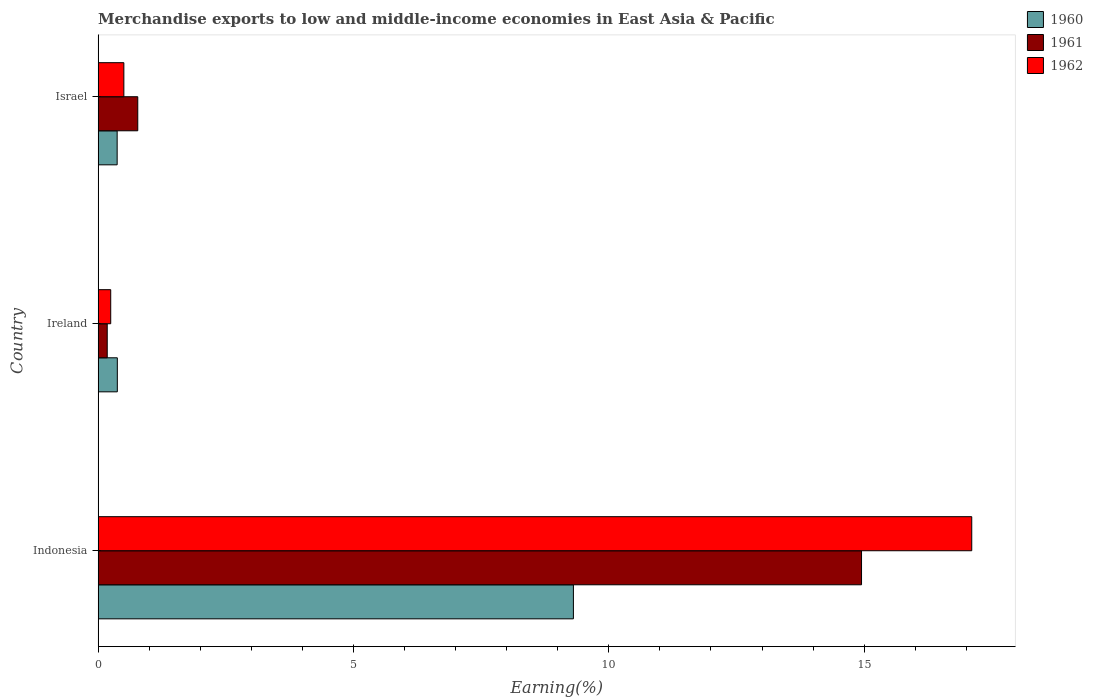How many groups of bars are there?
Give a very brief answer. 3. Are the number of bars per tick equal to the number of legend labels?
Your response must be concise. Yes. Are the number of bars on each tick of the Y-axis equal?
Provide a short and direct response. Yes. How many bars are there on the 2nd tick from the top?
Make the answer very short. 3. How many bars are there on the 2nd tick from the bottom?
Provide a short and direct response. 3. What is the label of the 1st group of bars from the top?
Your answer should be compact. Israel. What is the percentage of amount earned from merchandise exports in 1960 in Indonesia?
Keep it short and to the point. 9.31. Across all countries, what is the maximum percentage of amount earned from merchandise exports in 1960?
Provide a succinct answer. 9.31. Across all countries, what is the minimum percentage of amount earned from merchandise exports in 1960?
Give a very brief answer. 0.37. In which country was the percentage of amount earned from merchandise exports in 1961 maximum?
Your answer should be compact. Indonesia. In which country was the percentage of amount earned from merchandise exports in 1961 minimum?
Keep it short and to the point. Ireland. What is the total percentage of amount earned from merchandise exports in 1962 in the graph?
Offer a very short reply. 17.86. What is the difference between the percentage of amount earned from merchandise exports in 1962 in Ireland and that in Israel?
Ensure brevity in your answer.  -0.26. What is the difference between the percentage of amount earned from merchandise exports in 1962 in Israel and the percentage of amount earned from merchandise exports in 1960 in Ireland?
Your answer should be very brief. 0.13. What is the average percentage of amount earned from merchandise exports in 1961 per country?
Provide a succinct answer. 5.3. What is the difference between the percentage of amount earned from merchandise exports in 1962 and percentage of amount earned from merchandise exports in 1960 in Indonesia?
Ensure brevity in your answer.  7.8. In how many countries, is the percentage of amount earned from merchandise exports in 1961 greater than 6 %?
Ensure brevity in your answer.  1. What is the ratio of the percentage of amount earned from merchandise exports in 1961 in Indonesia to that in Ireland?
Make the answer very short. 83.74. Is the percentage of amount earned from merchandise exports in 1960 in Indonesia less than that in Israel?
Provide a succinct answer. No. What is the difference between the highest and the second highest percentage of amount earned from merchandise exports in 1962?
Your answer should be compact. 16.6. What is the difference between the highest and the lowest percentage of amount earned from merchandise exports in 1961?
Your answer should be compact. 14.77. In how many countries, is the percentage of amount earned from merchandise exports in 1960 greater than the average percentage of amount earned from merchandise exports in 1960 taken over all countries?
Offer a very short reply. 1. Is the sum of the percentage of amount earned from merchandise exports in 1960 in Indonesia and Israel greater than the maximum percentage of amount earned from merchandise exports in 1961 across all countries?
Provide a succinct answer. No. What does the 3rd bar from the bottom in Israel represents?
Make the answer very short. 1962. Is it the case that in every country, the sum of the percentage of amount earned from merchandise exports in 1961 and percentage of amount earned from merchandise exports in 1960 is greater than the percentage of amount earned from merchandise exports in 1962?
Give a very brief answer. Yes. How many bars are there?
Provide a succinct answer. 9. What is the difference between two consecutive major ticks on the X-axis?
Provide a succinct answer. 5. Does the graph contain any zero values?
Your answer should be compact. No. Does the graph contain grids?
Ensure brevity in your answer.  No. Where does the legend appear in the graph?
Offer a terse response. Top right. How many legend labels are there?
Your response must be concise. 3. How are the legend labels stacked?
Give a very brief answer. Vertical. What is the title of the graph?
Your response must be concise. Merchandise exports to low and middle-income economies in East Asia & Pacific. What is the label or title of the X-axis?
Make the answer very short. Earning(%). What is the label or title of the Y-axis?
Offer a terse response. Country. What is the Earning(%) of 1960 in Indonesia?
Keep it short and to the point. 9.31. What is the Earning(%) in 1961 in Indonesia?
Your response must be concise. 14.95. What is the Earning(%) of 1962 in Indonesia?
Make the answer very short. 17.11. What is the Earning(%) of 1960 in Ireland?
Ensure brevity in your answer.  0.38. What is the Earning(%) in 1961 in Ireland?
Give a very brief answer. 0.18. What is the Earning(%) of 1962 in Ireland?
Give a very brief answer. 0.25. What is the Earning(%) in 1960 in Israel?
Your answer should be very brief. 0.37. What is the Earning(%) of 1961 in Israel?
Your answer should be compact. 0.78. What is the Earning(%) of 1962 in Israel?
Offer a very short reply. 0.5. Across all countries, what is the maximum Earning(%) in 1960?
Offer a very short reply. 9.31. Across all countries, what is the maximum Earning(%) in 1961?
Keep it short and to the point. 14.95. Across all countries, what is the maximum Earning(%) of 1962?
Provide a short and direct response. 17.11. Across all countries, what is the minimum Earning(%) of 1960?
Your response must be concise. 0.37. Across all countries, what is the minimum Earning(%) in 1961?
Make the answer very short. 0.18. Across all countries, what is the minimum Earning(%) of 1962?
Offer a terse response. 0.25. What is the total Earning(%) in 1960 in the graph?
Your answer should be compact. 10.06. What is the total Earning(%) of 1961 in the graph?
Your response must be concise. 15.9. What is the total Earning(%) of 1962 in the graph?
Make the answer very short. 17.86. What is the difference between the Earning(%) of 1960 in Indonesia and that in Ireland?
Offer a very short reply. 8.93. What is the difference between the Earning(%) of 1961 in Indonesia and that in Ireland?
Your response must be concise. 14.77. What is the difference between the Earning(%) in 1962 in Indonesia and that in Ireland?
Your response must be concise. 16.86. What is the difference between the Earning(%) in 1960 in Indonesia and that in Israel?
Give a very brief answer. 8.93. What is the difference between the Earning(%) of 1961 in Indonesia and that in Israel?
Give a very brief answer. 14.17. What is the difference between the Earning(%) in 1962 in Indonesia and that in Israel?
Keep it short and to the point. 16.6. What is the difference between the Earning(%) in 1960 in Ireland and that in Israel?
Your response must be concise. 0. What is the difference between the Earning(%) of 1961 in Ireland and that in Israel?
Keep it short and to the point. -0.6. What is the difference between the Earning(%) in 1962 in Ireland and that in Israel?
Your answer should be compact. -0.26. What is the difference between the Earning(%) in 1960 in Indonesia and the Earning(%) in 1961 in Ireland?
Ensure brevity in your answer.  9.13. What is the difference between the Earning(%) in 1960 in Indonesia and the Earning(%) in 1962 in Ireland?
Keep it short and to the point. 9.06. What is the difference between the Earning(%) of 1961 in Indonesia and the Earning(%) of 1962 in Ireland?
Make the answer very short. 14.7. What is the difference between the Earning(%) in 1960 in Indonesia and the Earning(%) in 1961 in Israel?
Make the answer very short. 8.53. What is the difference between the Earning(%) in 1960 in Indonesia and the Earning(%) in 1962 in Israel?
Offer a terse response. 8.8. What is the difference between the Earning(%) of 1961 in Indonesia and the Earning(%) of 1962 in Israel?
Your answer should be very brief. 14.44. What is the difference between the Earning(%) of 1960 in Ireland and the Earning(%) of 1961 in Israel?
Ensure brevity in your answer.  -0.4. What is the difference between the Earning(%) of 1960 in Ireland and the Earning(%) of 1962 in Israel?
Ensure brevity in your answer.  -0.13. What is the difference between the Earning(%) in 1961 in Ireland and the Earning(%) in 1962 in Israel?
Make the answer very short. -0.33. What is the average Earning(%) of 1960 per country?
Ensure brevity in your answer.  3.35. What is the average Earning(%) in 1961 per country?
Make the answer very short. 5.3. What is the average Earning(%) in 1962 per country?
Your answer should be compact. 5.95. What is the difference between the Earning(%) in 1960 and Earning(%) in 1961 in Indonesia?
Your answer should be compact. -5.64. What is the difference between the Earning(%) of 1960 and Earning(%) of 1962 in Indonesia?
Provide a succinct answer. -7.8. What is the difference between the Earning(%) in 1961 and Earning(%) in 1962 in Indonesia?
Ensure brevity in your answer.  -2.16. What is the difference between the Earning(%) of 1960 and Earning(%) of 1961 in Ireland?
Give a very brief answer. 0.2. What is the difference between the Earning(%) of 1960 and Earning(%) of 1962 in Ireland?
Your answer should be very brief. 0.13. What is the difference between the Earning(%) in 1961 and Earning(%) in 1962 in Ireland?
Give a very brief answer. -0.07. What is the difference between the Earning(%) of 1960 and Earning(%) of 1961 in Israel?
Keep it short and to the point. -0.4. What is the difference between the Earning(%) in 1960 and Earning(%) in 1962 in Israel?
Your answer should be compact. -0.13. What is the difference between the Earning(%) of 1961 and Earning(%) of 1962 in Israel?
Offer a very short reply. 0.27. What is the ratio of the Earning(%) in 1960 in Indonesia to that in Ireland?
Your answer should be very brief. 24.74. What is the ratio of the Earning(%) in 1961 in Indonesia to that in Ireland?
Keep it short and to the point. 83.74. What is the ratio of the Earning(%) of 1962 in Indonesia to that in Ireland?
Make the answer very short. 69.36. What is the ratio of the Earning(%) of 1960 in Indonesia to that in Israel?
Your response must be concise. 24.96. What is the ratio of the Earning(%) in 1961 in Indonesia to that in Israel?
Offer a terse response. 19.25. What is the ratio of the Earning(%) of 1962 in Indonesia to that in Israel?
Keep it short and to the point. 33.94. What is the ratio of the Earning(%) of 1960 in Ireland to that in Israel?
Keep it short and to the point. 1.01. What is the ratio of the Earning(%) of 1961 in Ireland to that in Israel?
Your answer should be very brief. 0.23. What is the ratio of the Earning(%) of 1962 in Ireland to that in Israel?
Your answer should be compact. 0.49. What is the difference between the highest and the second highest Earning(%) in 1960?
Your answer should be very brief. 8.93. What is the difference between the highest and the second highest Earning(%) of 1961?
Make the answer very short. 14.17. What is the difference between the highest and the second highest Earning(%) of 1962?
Your answer should be very brief. 16.6. What is the difference between the highest and the lowest Earning(%) in 1960?
Keep it short and to the point. 8.93. What is the difference between the highest and the lowest Earning(%) of 1961?
Provide a succinct answer. 14.77. What is the difference between the highest and the lowest Earning(%) in 1962?
Your answer should be compact. 16.86. 